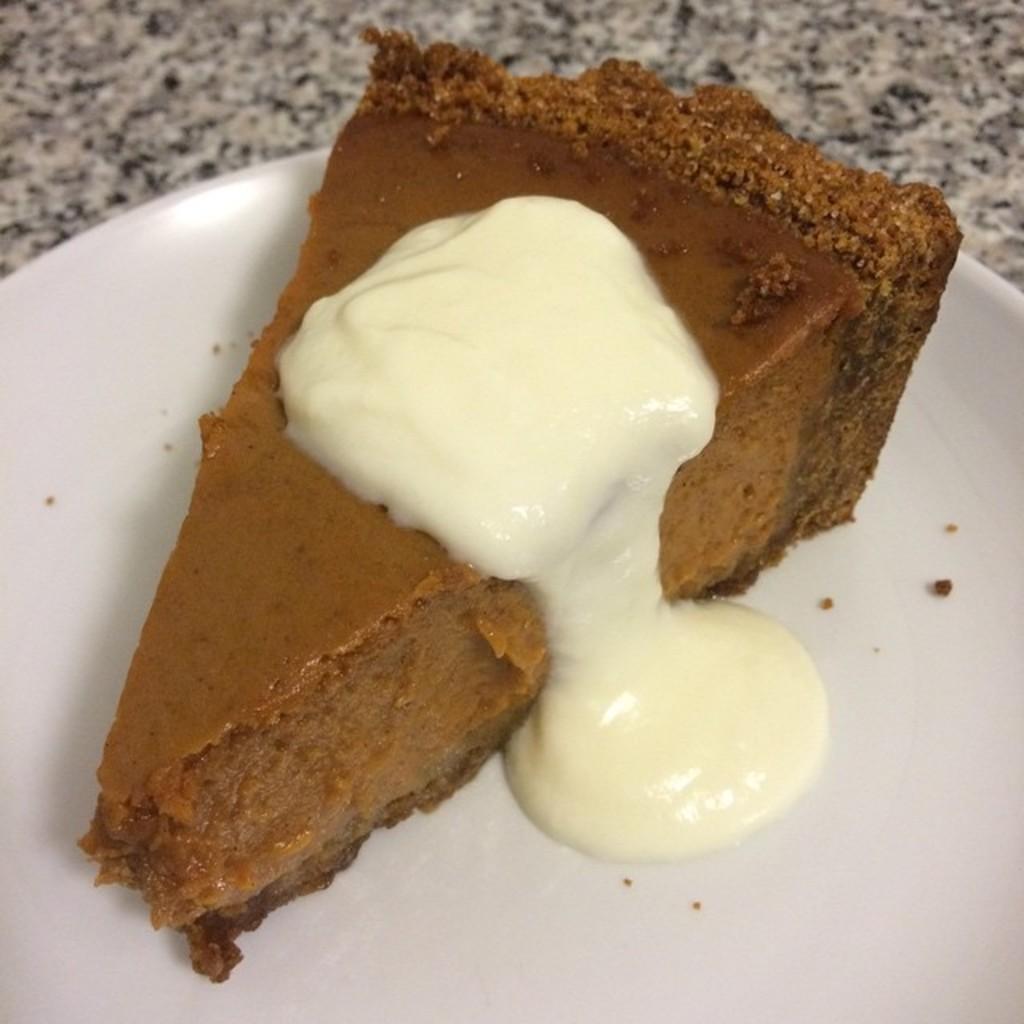Can you describe this image briefly? In this picture we can see a plate on the surface with cake in it. 